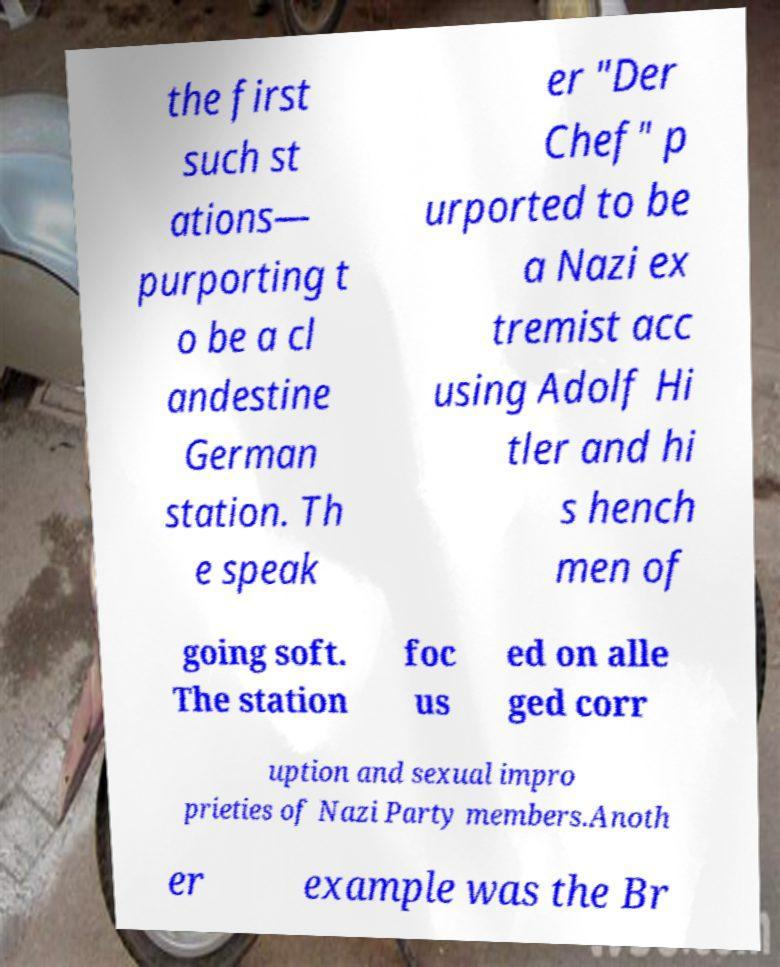Can you accurately transcribe the text from the provided image for me? the first such st ations— purporting t o be a cl andestine German station. Th e speak er "Der Chef" p urported to be a Nazi ex tremist acc using Adolf Hi tler and hi s hench men of going soft. The station foc us ed on alle ged corr uption and sexual impro prieties of Nazi Party members.Anoth er example was the Br 